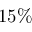<formula> <loc_0><loc_0><loc_500><loc_500>1 5 \%</formula> 